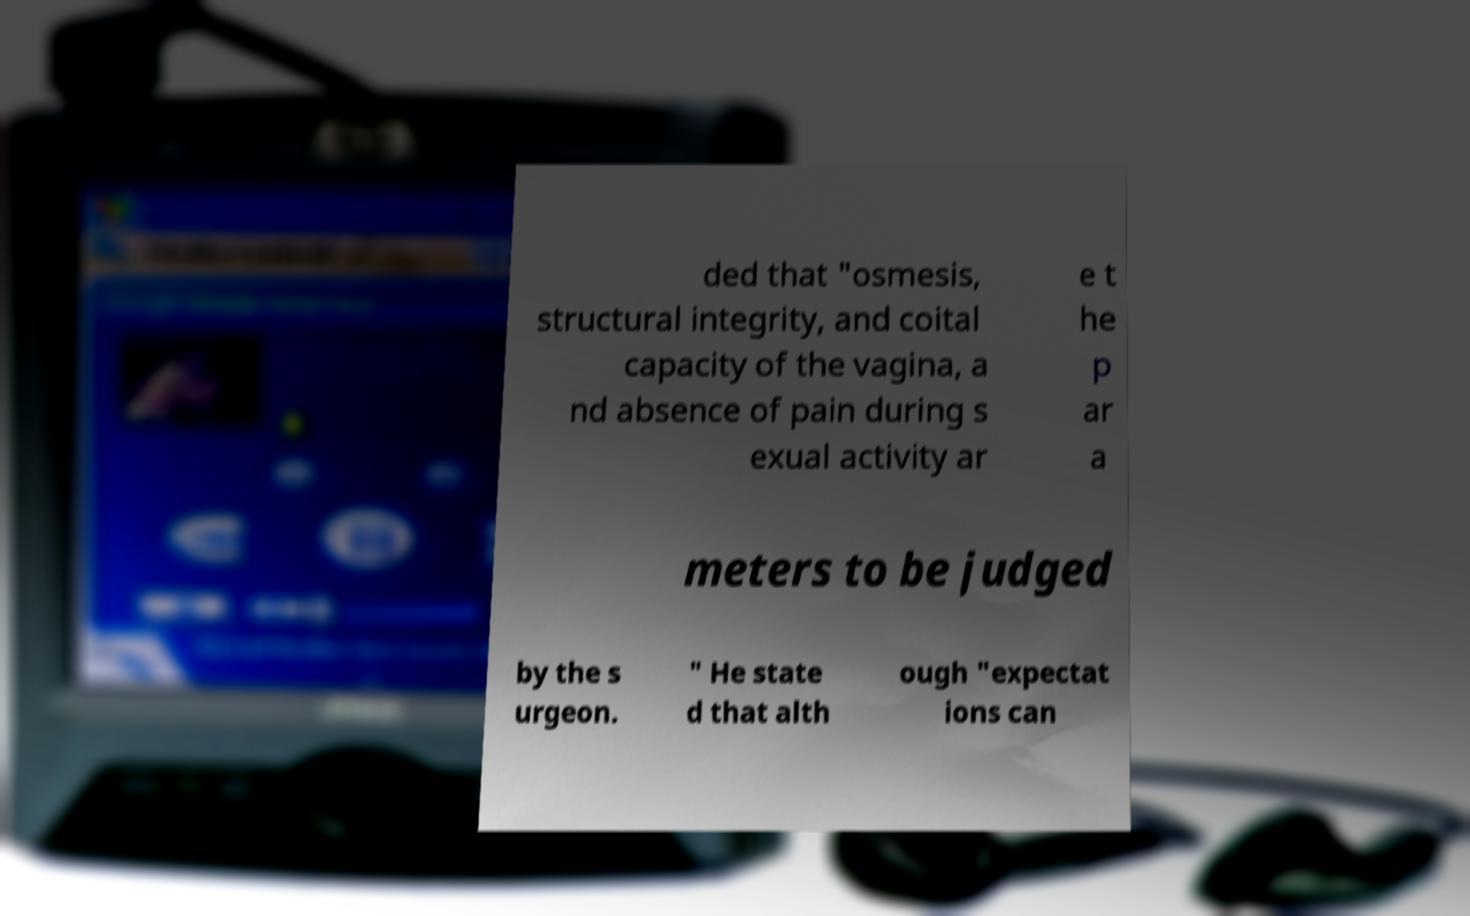There's text embedded in this image that I need extracted. Can you transcribe it verbatim? ded that "osmesis, structural integrity, and coital capacity of the vagina, a nd absence of pain during s exual activity ar e t he p ar a meters to be judged by the s urgeon. " He state d that alth ough "expectat ions can 